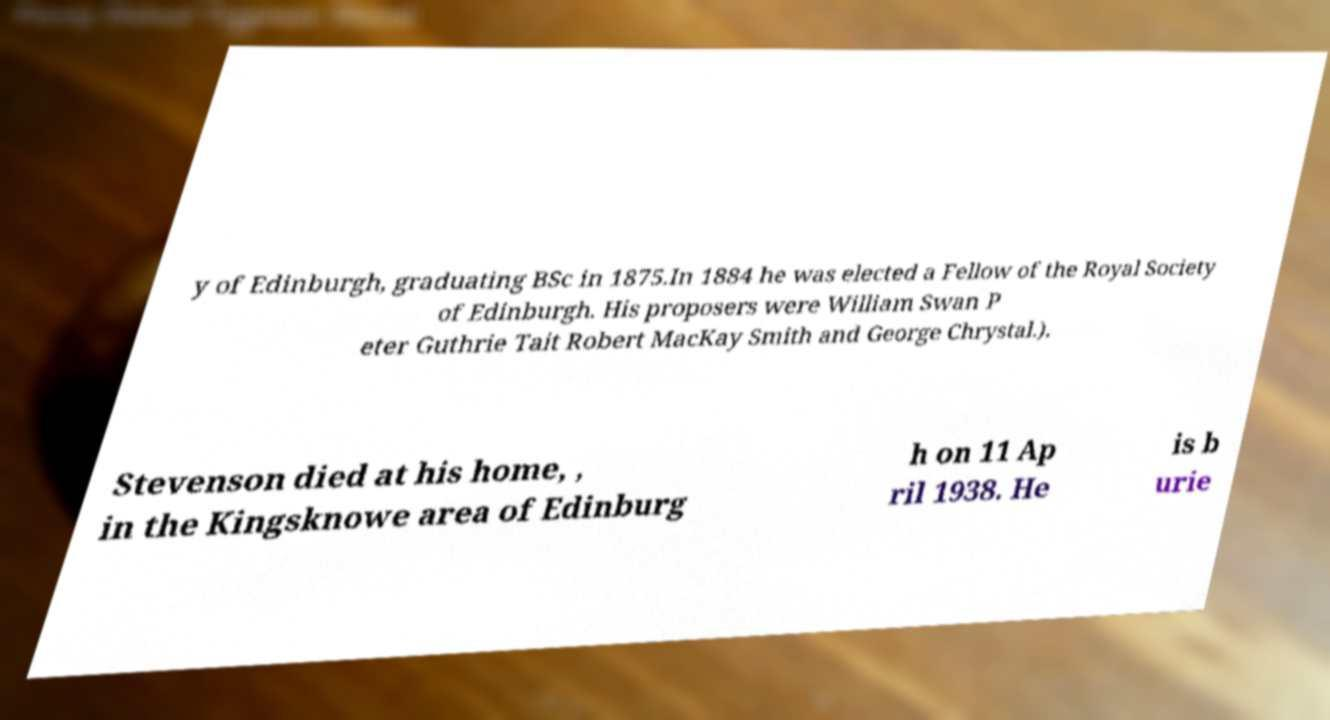There's text embedded in this image that I need extracted. Can you transcribe it verbatim? y of Edinburgh, graduating BSc in 1875.In 1884 he was elected a Fellow of the Royal Society of Edinburgh. His proposers were William Swan P eter Guthrie Tait Robert MacKay Smith and George Chrystal.). Stevenson died at his home, , in the Kingsknowe area of Edinburg h on 11 Ap ril 1938. He is b urie 